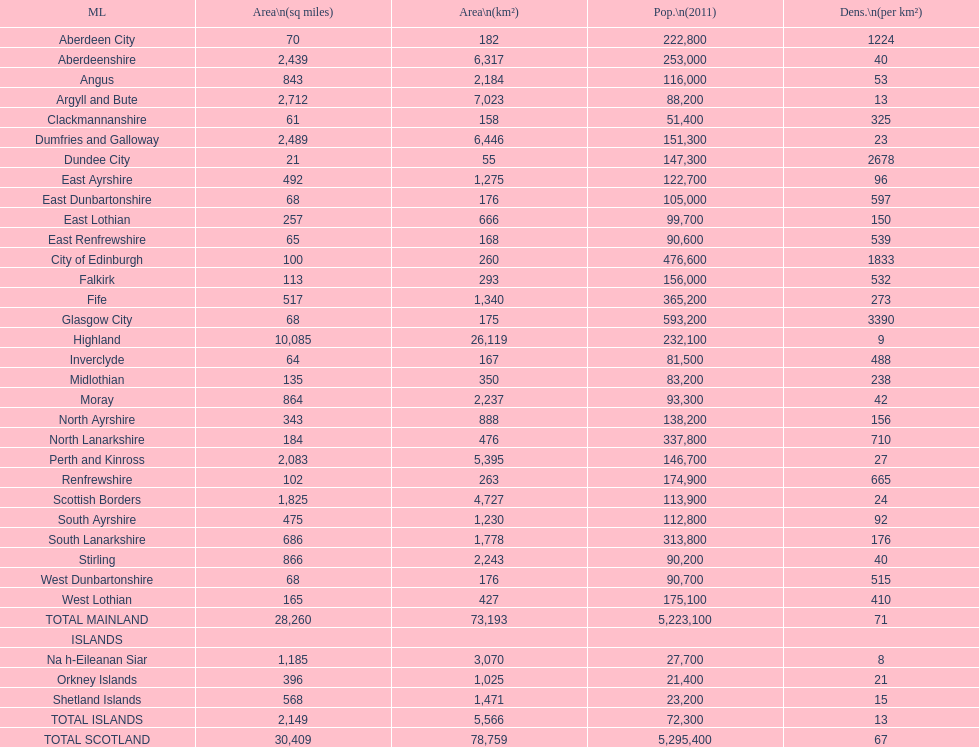What is the difference in square miles from angus and fife? 326. 